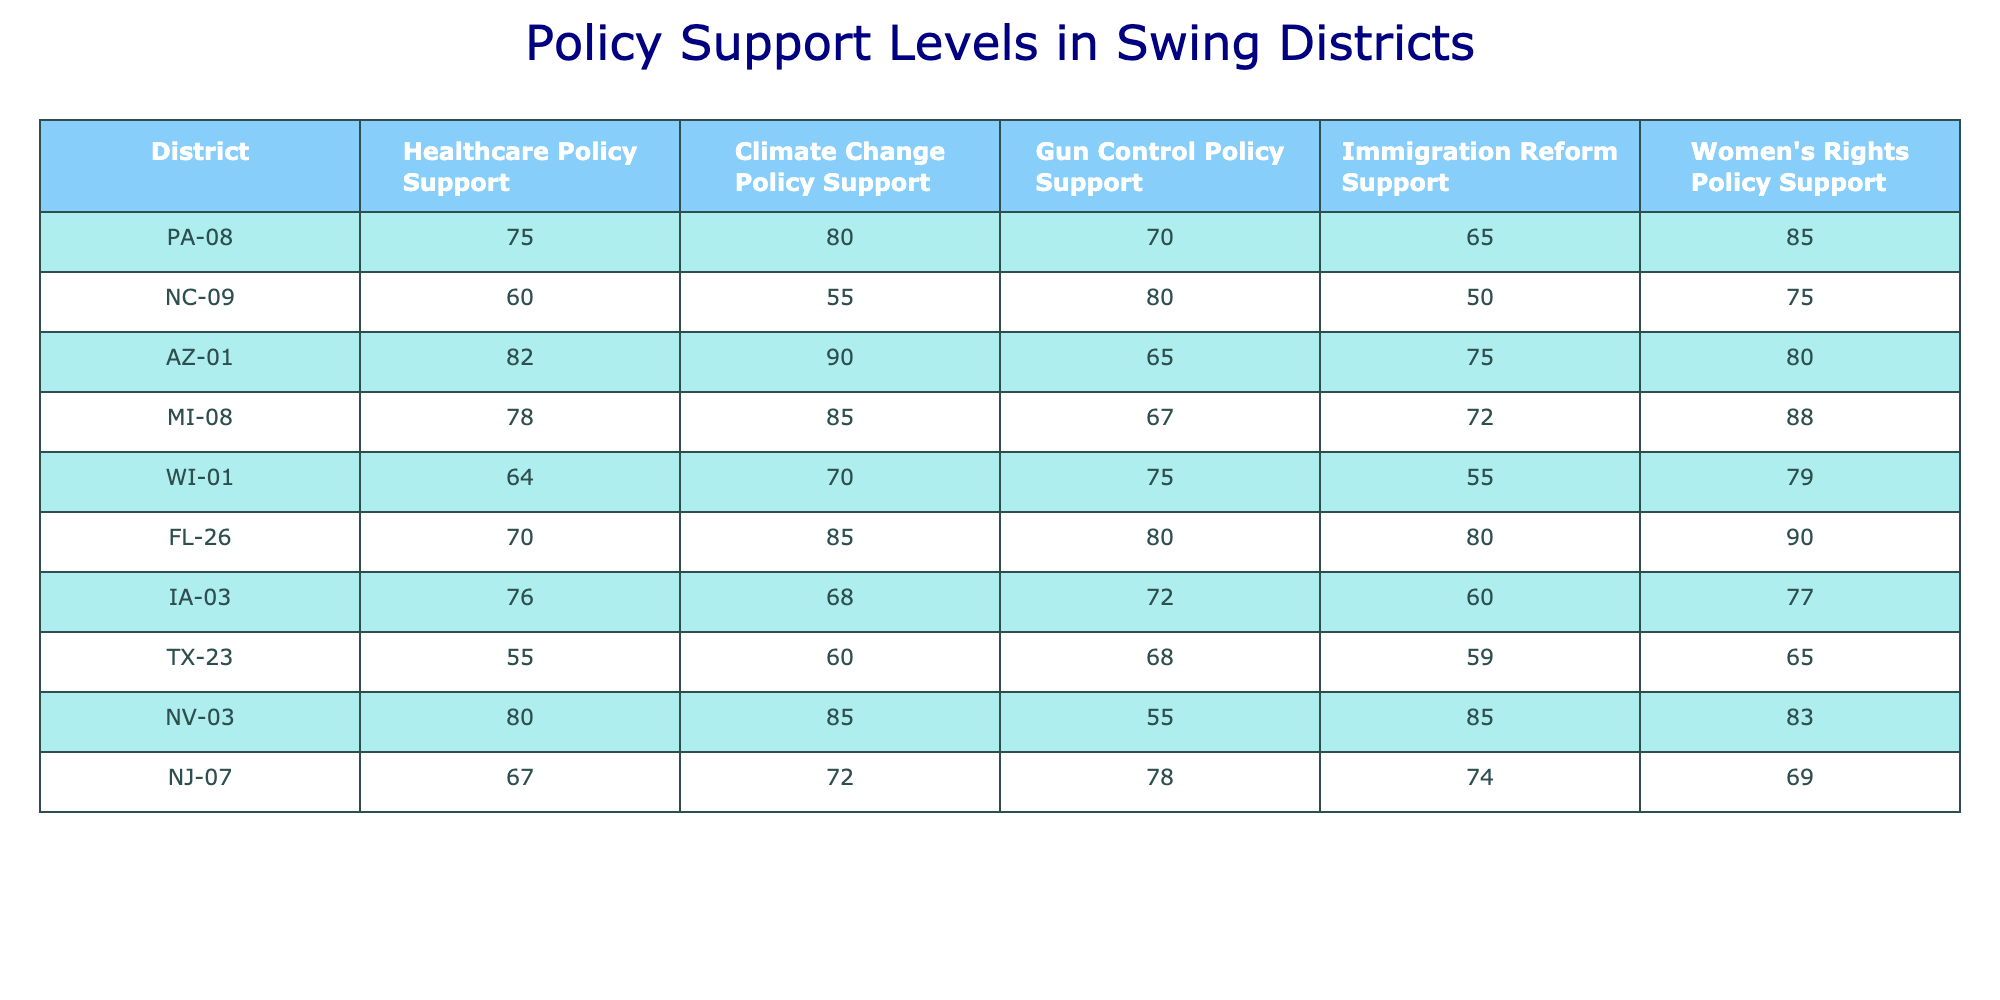What's the highest level of support for Climate Change Policy among the districts? Checking the "Climate Change Policy Support" column, the highest value is 90, which is found in Arizona's 1st district.
Answer: 90 Which district has the lowest support for Gun Control Policy? In the "Gun Control Policy Support" column, Texas's 23rd district has the lowest value of 55.
Answer: 55 What is the average support level for Immigration Reform across all the districts? Adding the values from the "Immigration Reform Support" column: (65 + 50 + 75 + 72 + 55 + 80 + 60 + 59 + 85 + 74) =  746, and dividing by 10 gives an average of 74.6.
Answer: 74.6 Is the support for Women's Rights Policy in Michigan's 8th district higher than in Pennsylvania's 8th district? Comparing the values: Michigan's support is 88 and Pennsylvania's is 85, thus, Michigan has higher support.
Answer: Yes What is the difference in support levels for Healthcare Policy between PA-08 and NC-09? For Healthcare Policy Support, PA-08 has 75 and NC-09 has 60. The difference is 75 - 60 = 15.
Answer: 15 Which district has the second-highest support for Climate Change Policy? The highest is 90 in AZ-01, looking for the next highest, MI-08 has 85, making it the second-highest.
Answer: MI-08 Are constituents in WI-01 more supportive of Women's Rights Policy than those in TX-23? In WI-01, support is 79 and in TX-23 it is 65, so yes, constituents in WI-01 are more supportive.
Answer: Yes What is the total support level for all policies in NC-09? Adding all support levels for NC-09: 60 + 55 + 80 + 50 + 75 = 320.
Answer: 320 Does NV-03 have a higher support level for Healthcare Policy compared to the average of all districts? NV-03 has 80, and the average for Healthcare Policy can be calculated as (75+60+82+78+64+70+76+55+80+67)/10 = 71.7, and 80 is indeed higher than 71.7.
Answer: Yes Which policy has the highest overall average support among all districts? Calculating the average support for each policy: Healthcare (71.7), Climate Change (77.5), Gun Control (70.5), Immigration Reform (74.6), Women's Rights (77.3); Climate Change has the highest average at 77.5.
Answer: Climate Change 